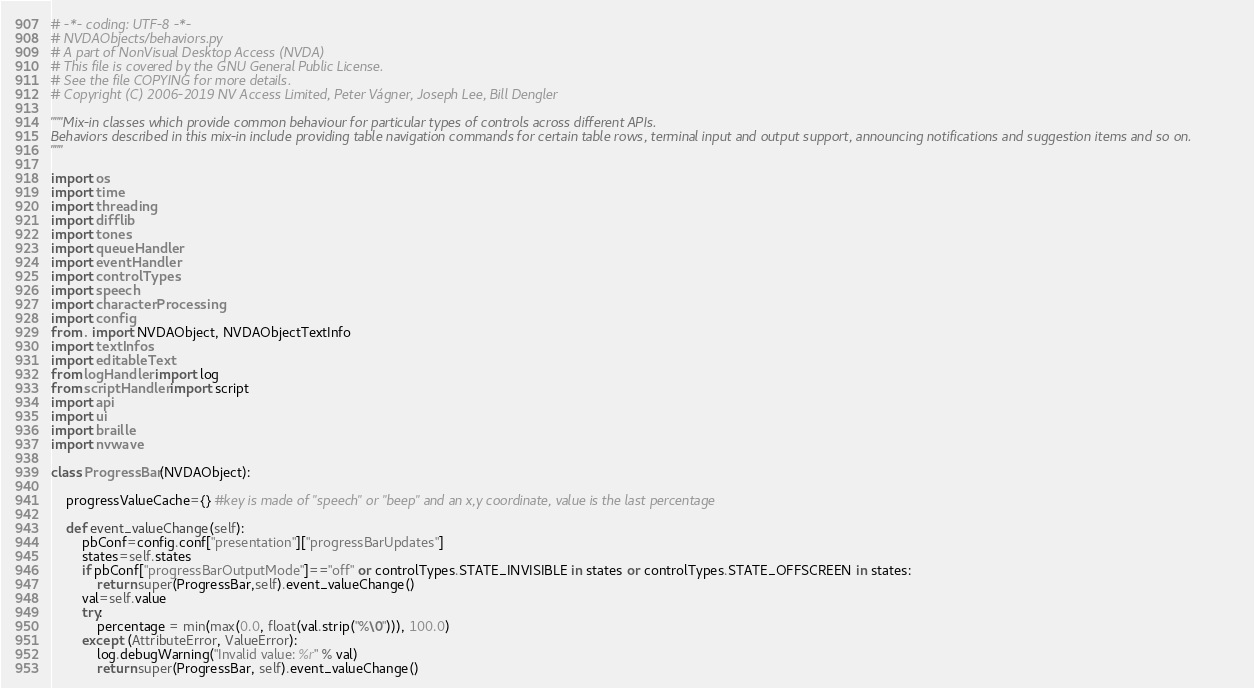Convert code to text. <code><loc_0><loc_0><loc_500><loc_500><_Python_># -*- coding: UTF-8 -*-
# NVDAObjects/behaviors.py
# A part of NonVisual Desktop Access (NVDA)
# This file is covered by the GNU General Public License.
# See the file COPYING for more details.
# Copyright (C) 2006-2019 NV Access Limited, Peter Vágner, Joseph Lee, Bill Dengler

"""Mix-in classes which provide common behaviour for particular types of controls across different APIs.
Behaviors described in this mix-in include providing table navigation commands for certain table rows, terminal input and output support, announcing notifications and suggestion items and so on.
"""

import os
import time
import threading
import difflib
import tones
import queueHandler
import eventHandler
import controlTypes
import speech
import characterProcessing
import config
from . import NVDAObject, NVDAObjectTextInfo
import textInfos
import editableText
from logHandler import log
from scriptHandler import script
import api
import ui
import braille
import nvwave

class ProgressBar(NVDAObject):

	progressValueCache={} #key is made of "speech" or "beep" and an x,y coordinate, value is the last percentage

	def event_valueChange(self):
		pbConf=config.conf["presentation"]["progressBarUpdates"]
		states=self.states
		if pbConf["progressBarOutputMode"]=="off" or controlTypes.STATE_INVISIBLE in states or controlTypes.STATE_OFFSCREEN in states:
			return super(ProgressBar,self).event_valueChange()
		val=self.value
		try:
			percentage = min(max(0.0, float(val.strip("%\0"))), 100.0)
		except (AttributeError, ValueError):
			log.debugWarning("Invalid value: %r" % val)
			return super(ProgressBar, self).event_valueChange()</code> 